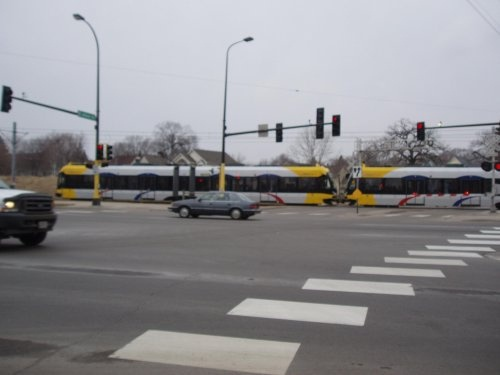Describe the objects in this image and their specific colors. I can see train in lightgray, black, gray, darkgray, and olive tones, truck in lightgray, black, gray, and darkgray tones, car in lightgray, gray, and black tones, traffic light in lightgray, black, gray, darkgray, and maroon tones, and traffic light in lightgray, black, gray, and purple tones in this image. 